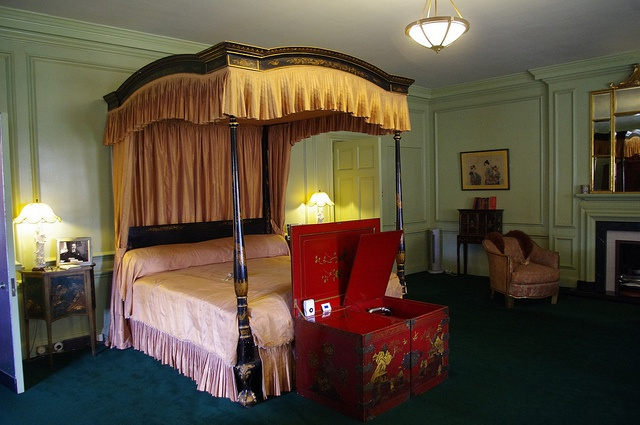Describe the objects in this image and their specific colors. I can see bed in black, maroon, and olive tones and chair in black, maroon, and gray tones in this image. 